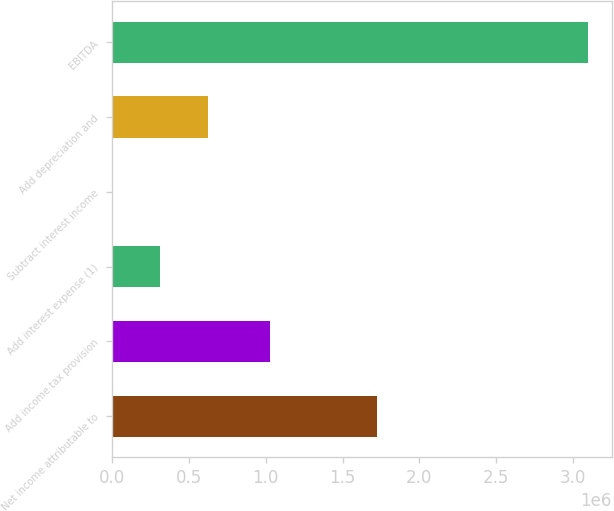Convert chart. <chart><loc_0><loc_0><loc_500><loc_500><bar_chart><fcel>Net income attributable to<fcel>Add income tax provision<fcel>Add interest expense (1)<fcel>Subtract interest income<fcel>Add depreciation and<fcel>EBITDA<nl><fcel>1.72717e+06<fcel>1.02796e+06<fcel>314048<fcel>4786<fcel>623309<fcel>3.0974e+06<nl></chart> 